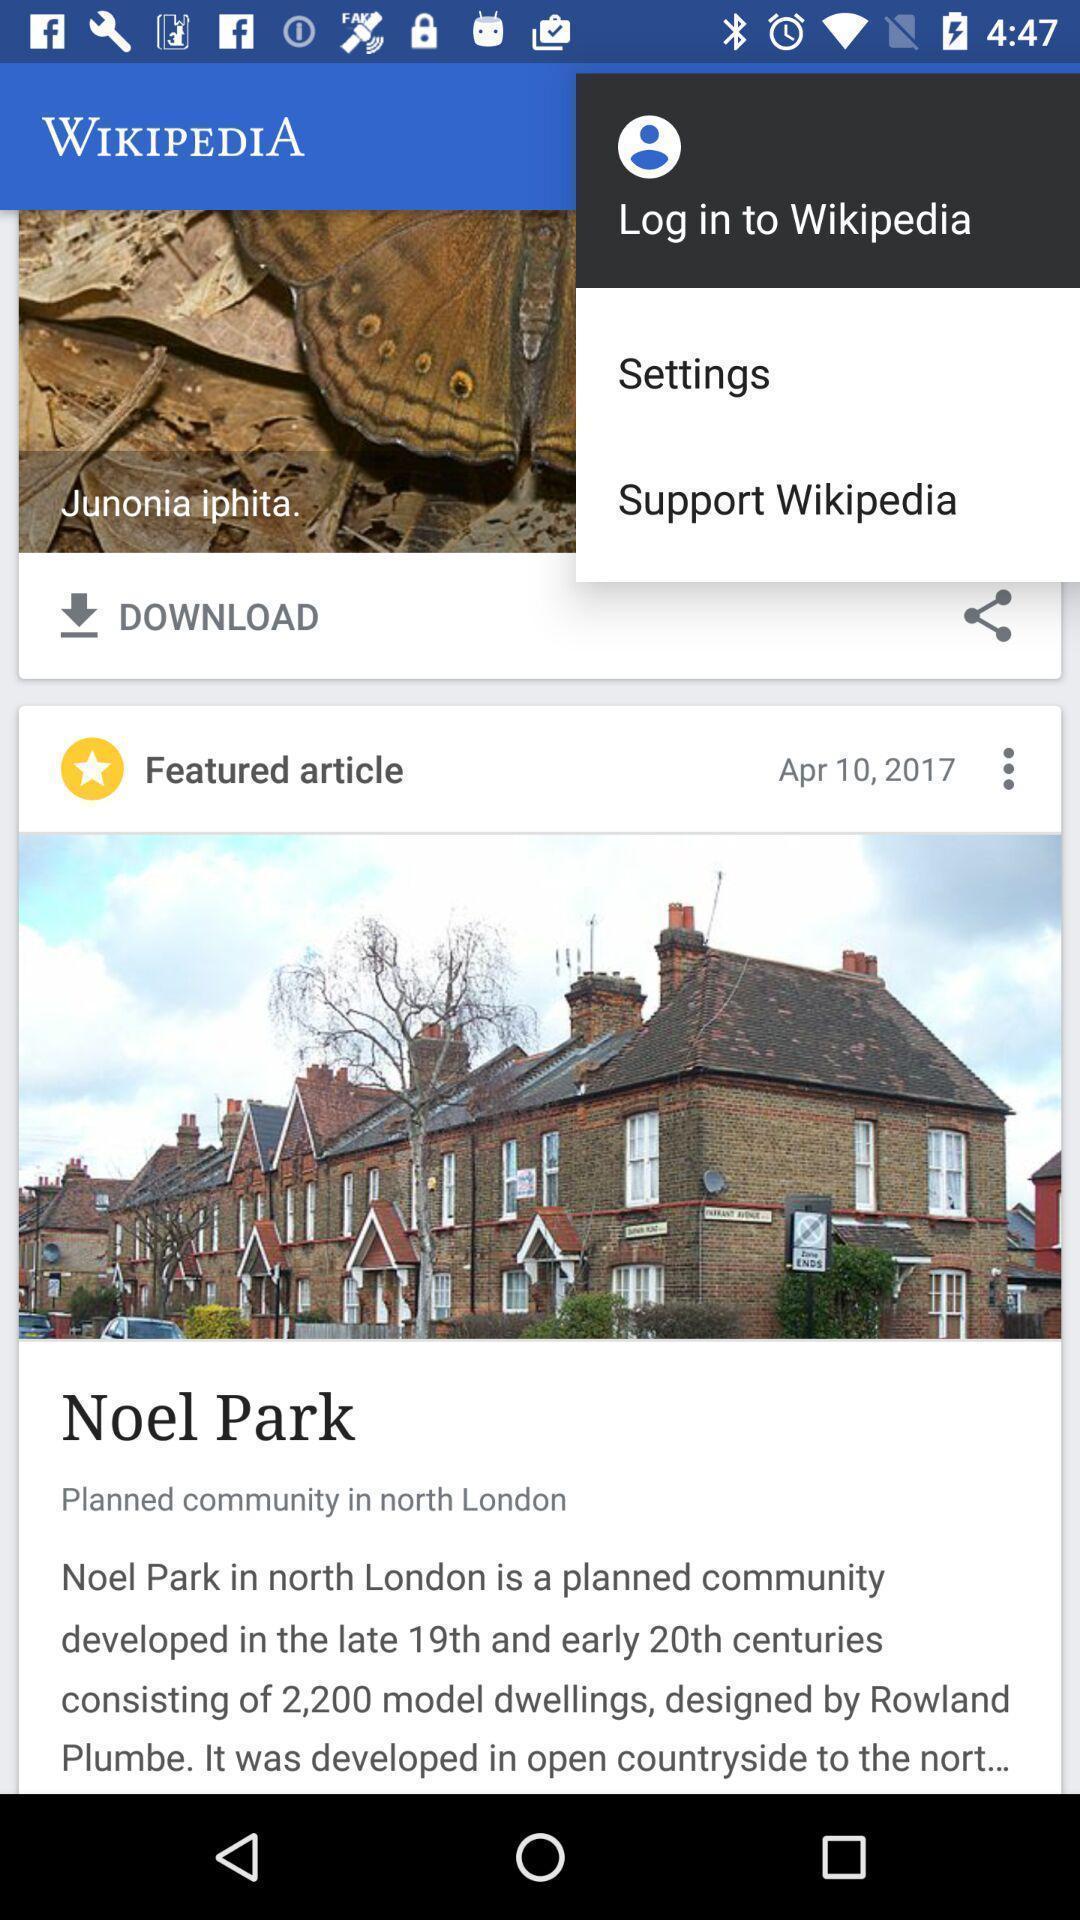Tell me what you see in this picture. Welcome page displaying login. 